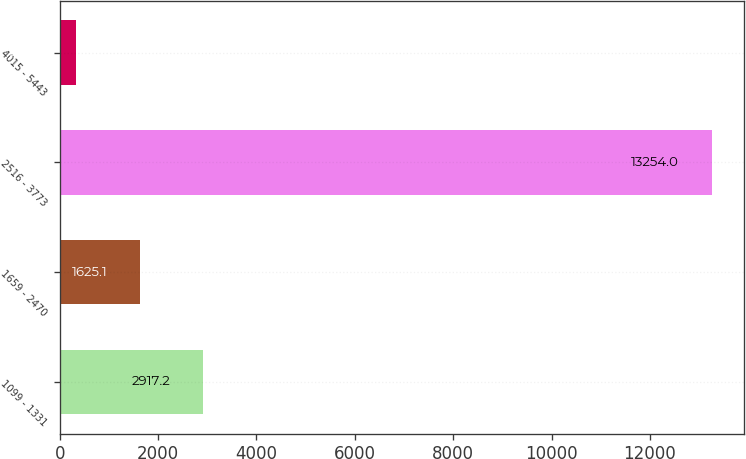<chart> <loc_0><loc_0><loc_500><loc_500><bar_chart><fcel>1099 - 1331<fcel>1659 - 2470<fcel>2516 - 3773<fcel>4015 - 5443<nl><fcel>2917.2<fcel>1625.1<fcel>13254<fcel>333<nl></chart> 